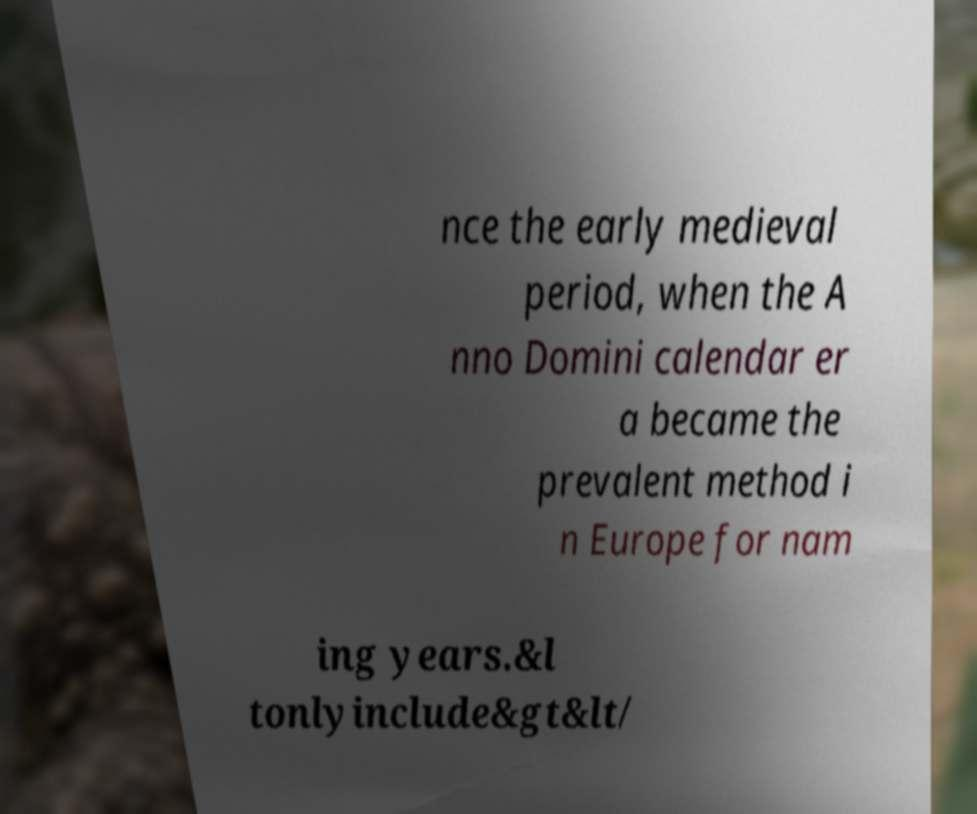Can you accurately transcribe the text from the provided image for me? nce the early medieval period, when the A nno Domini calendar er a became the prevalent method i n Europe for nam ing years.&l tonlyinclude&gt&lt/ 